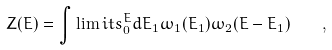<formula> <loc_0><loc_0><loc_500><loc_500>Z ( E ) = \int \lim i t s ^ { E } _ { 0 } d E _ { 1 } \omega _ { 1 } ( E _ { 1 } ) \omega _ { 2 } ( E - E _ { 1 } ) \quad ,</formula> 